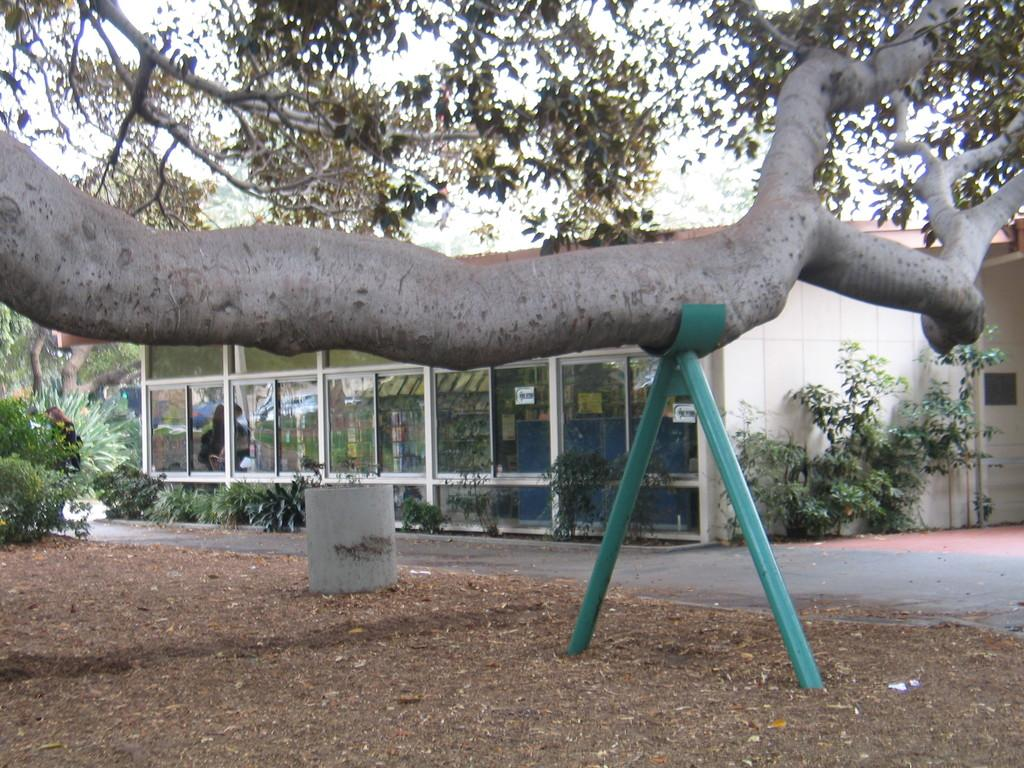What is being held together with an iron rod in the image? There is a tree branch held with an iron rod in the image. How are the tree branch and iron rod positioned in the image? The tree branch and iron rod are placed on the ground. What can be seen in the background of the image? There is a group of plants and a building in the background of the image. What type of balloon is being used to decorate the party in the image? There is no balloon or party present in the image; it features a tree branch held with an iron rod and a background with plants and a building. 